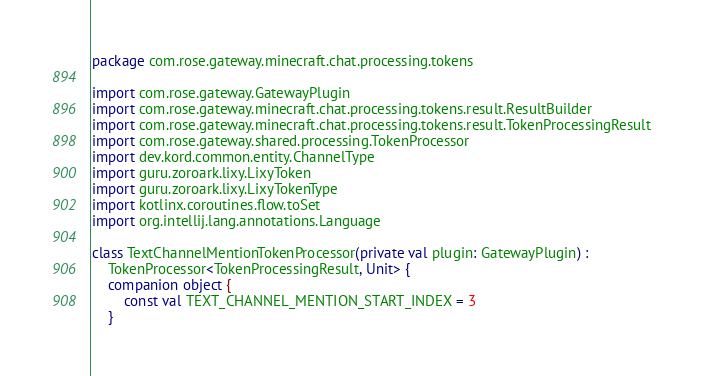Convert code to text. <code><loc_0><loc_0><loc_500><loc_500><_Kotlin_>package com.rose.gateway.minecraft.chat.processing.tokens

import com.rose.gateway.GatewayPlugin
import com.rose.gateway.minecraft.chat.processing.tokens.result.ResultBuilder
import com.rose.gateway.minecraft.chat.processing.tokens.result.TokenProcessingResult
import com.rose.gateway.shared.processing.TokenProcessor
import dev.kord.common.entity.ChannelType
import guru.zoroark.lixy.LixyToken
import guru.zoroark.lixy.LixyTokenType
import kotlinx.coroutines.flow.toSet
import org.intellij.lang.annotations.Language

class TextChannelMentionTokenProcessor(private val plugin: GatewayPlugin) :
    TokenProcessor<TokenProcessingResult, Unit> {
    companion object {
        const val TEXT_CHANNEL_MENTION_START_INDEX = 3
    }
</code> 